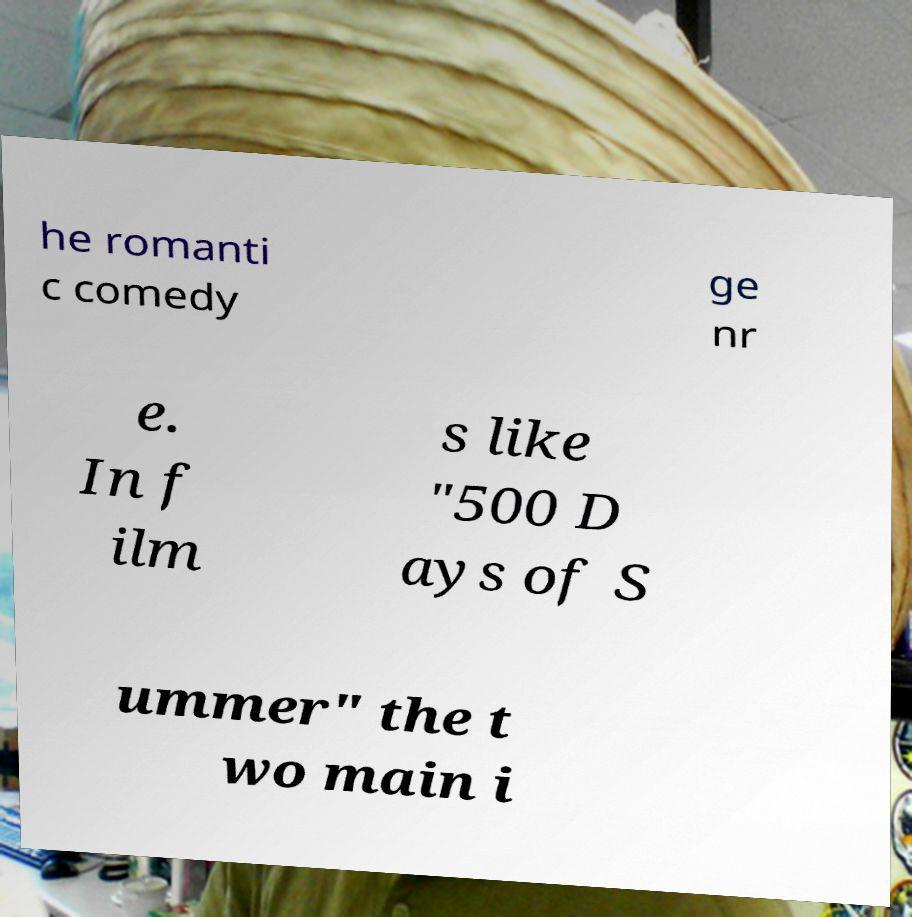What messages or text are displayed in this image? I need them in a readable, typed format. he romanti c comedy ge nr e. In f ilm s like "500 D ays of S ummer" the t wo main i 